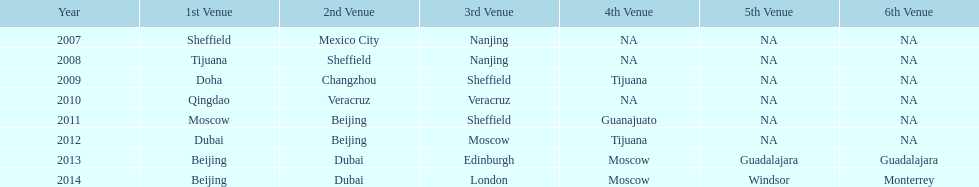Can you parse all the data within this table? {'header': ['Year', '1st Venue', '2nd Venue', '3rd Venue', '4th Venue', '5th Venue', '6th Venue'], 'rows': [['2007', 'Sheffield', 'Mexico City', 'Nanjing', 'NA', 'NA', 'NA'], ['2008', 'Tijuana', 'Sheffield', 'Nanjing', 'NA', 'NA', 'NA'], ['2009', 'Doha', 'Changzhou', 'Sheffield', 'Tijuana', 'NA', 'NA'], ['2010', 'Qingdao', 'Veracruz', 'Veracruz', 'NA', 'NA', 'NA'], ['2011', 'Moscow', 'Beijing', 'Sheffield', 'Guanajuato', 'NA', 'NA'], ['2012', 'Dubai', 'Beijing', 'Moscow', 'Tijuana', 'NA', 'NA'], ['2013', 'Beijing', 'Dubai', 'Edinburgh', 'Moscow', 'Guadalajara', 'Guadalajara'], ['2014', 'Beijing', 'Dubai', 'London', 'Moscow', 'Windsor', 'Monterrey']]} For how many years has this world series been taking place? 7 years. 